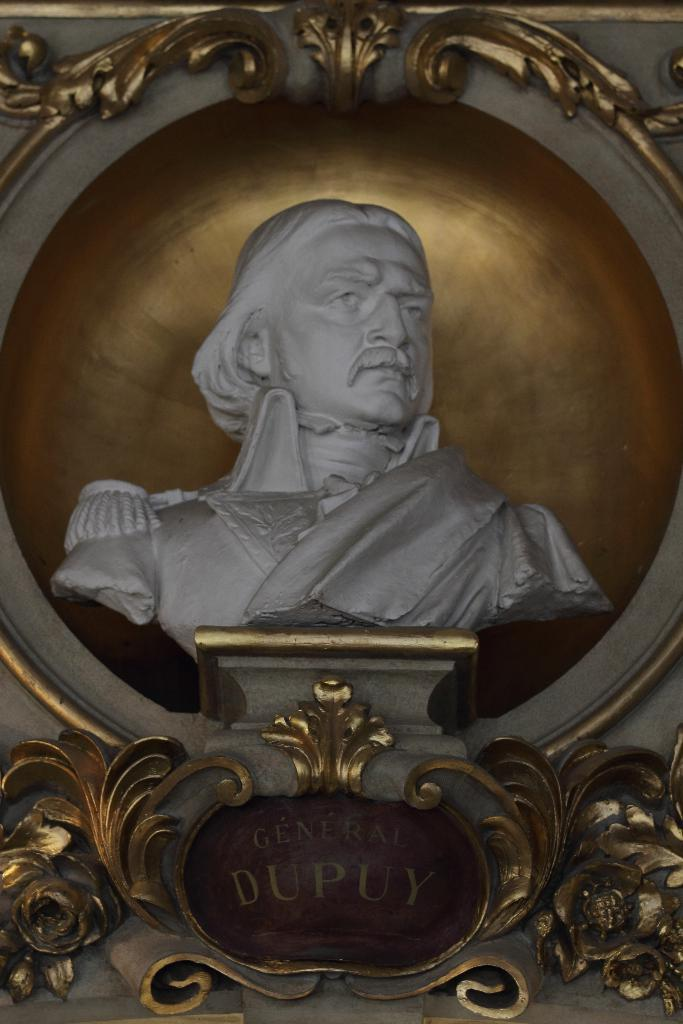What is the main subject in the center of the image? There is a sculpture in the center of the image. Is there any text associated with the sculpture or elsewhere in the image? Yes, there is some text in the image. What type of insect can be seen crawling on the sculpture in the image? There is no insect present on the sculpture in the image. How does the sculpture move or change position in the image? The sculpture is stationary in the image and does not move or change position. 